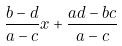<formula> <loc_0><loc_0><loc_500><loc_500>\frac { b - d } { a - c } x + \frac { a d - b c } { a - c }</formula> 